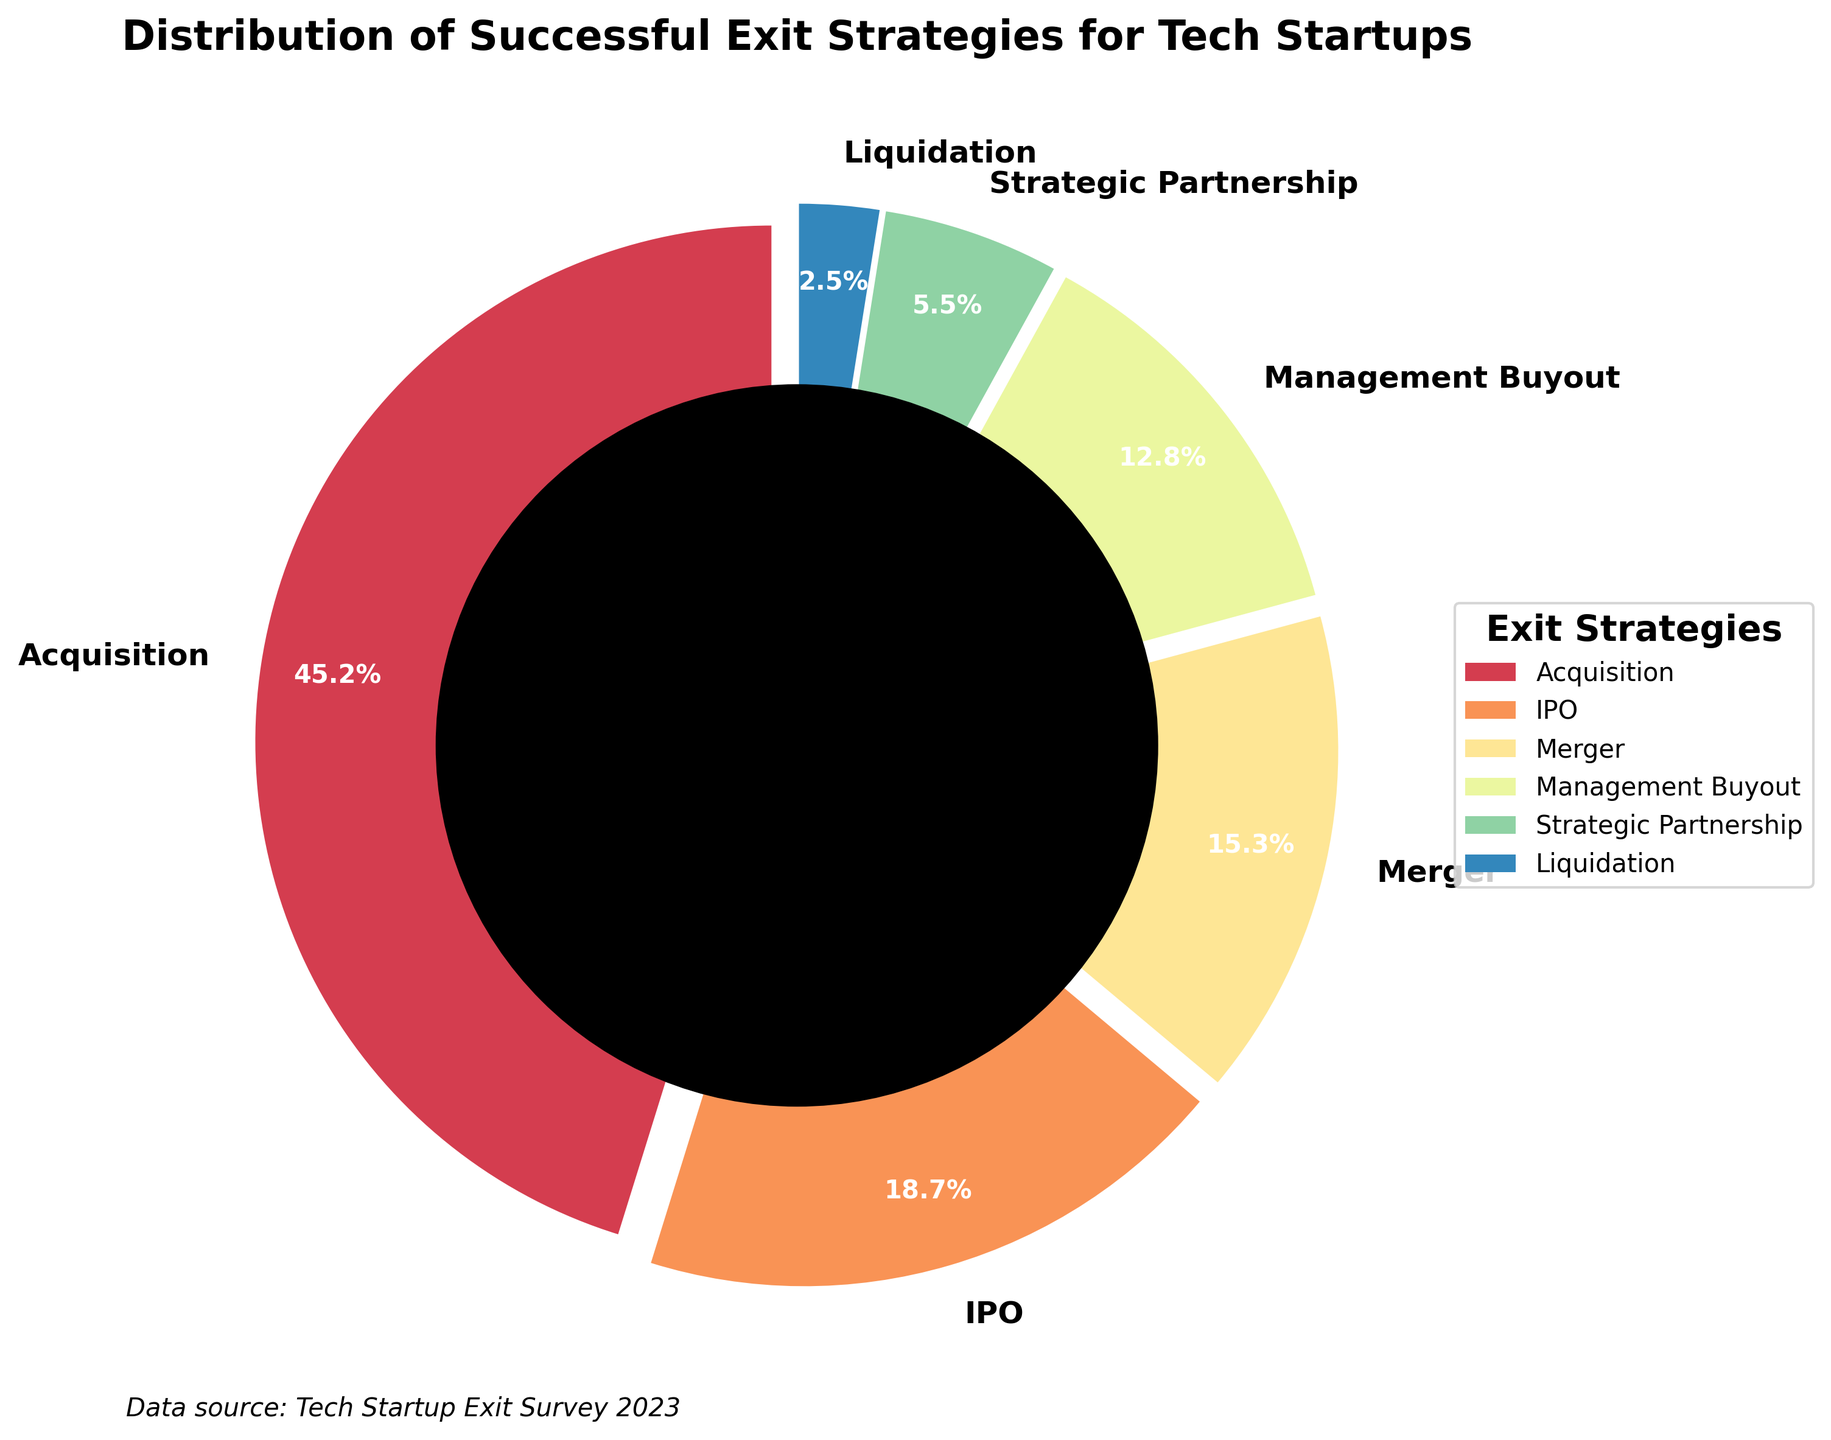What's the most common exit strategy for tech startups? The pie chart shows that acquisitions constitute the largest segment of the exit strategies for tech startups. Acquisition has the largest percentage (45.2%) among the different exit strategies displayed.
Answer: Acquisition What's the least common exit strategy? The smallest segment in the pie chart represents liquidation, which is only 2.5% of the total exit strategies.
Answer: Liquidation How many percentage points more common is an acquisition compared to an IPO? To find the difference, subtract the percentage of IPOs from the percentage of acquisitions: 45.2 - 18.7 = 26.5.
Answer: 26.5 If you combine the percentages of mergers and management buyouts, does their total surpass that of IPOs? Sum the percentages of mergers and management buyouts: 15.3 + 12.8 = 28.1. Since 28.1% is greater than 18.7%, the total surpasses that of IPOs.
Answer: Yes What are the exit strategies that constitute less than 10% each? The pie chart shows that strategic partnerships (5.5%) and liquidation (2.5%) both make up less than 10% of the total exit strategies.
Answer: Strategic Partnerships and Liquidation What percentage of the chart is taken up by strategies other than acquisition? Subtract the percentage of acquisitions from 100%: 100 - 45.2 = 54.8. Hence, the other strategies combined constitute 54.8% of the total.
Answer: 54.8 Are there more mergers or management buyouts? The percentage for mergers is 15.3%, while management buyouts are at 12.8%. Comparing these, mergers have a higher percentage.
Answer: Mergers What is the combined percentage of the three least common exit strategies? Add the percentages of management buyouts, strategic partnerships, and liquidation: 12.8 + 5.5 + 2.5 = 20.8.
Answer: 20.8 Which exit strategy has the darkest section in the chart? The pie chart uses shades from the Spectral color map. The darkest shade is generally assigned to the smallest segment, which is liquidation.
Answer: Liquidation 